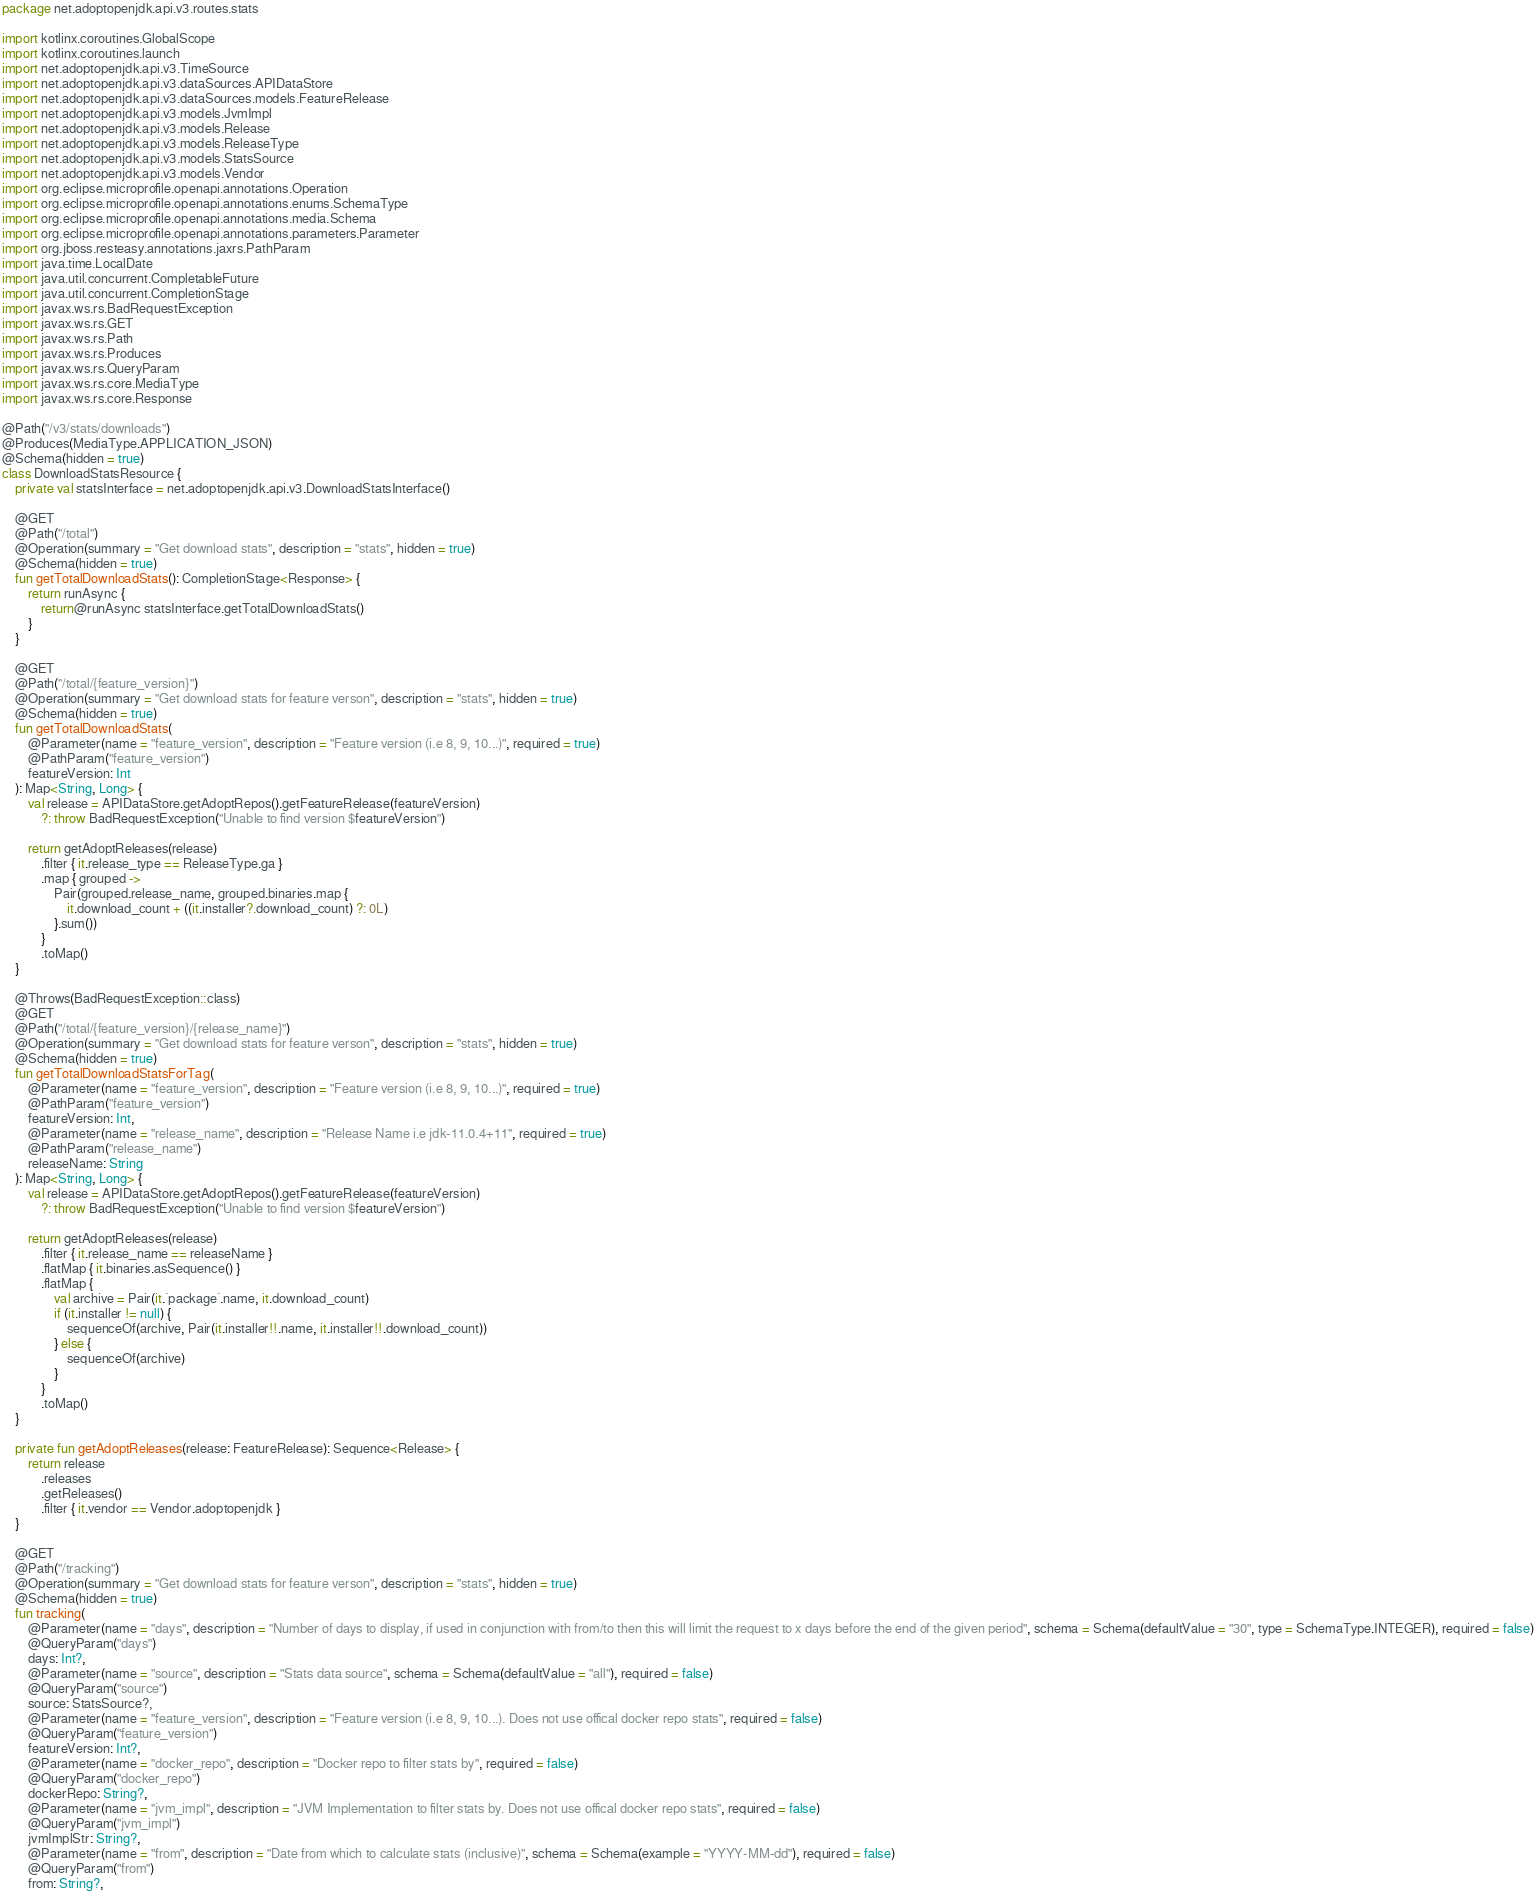Convert code to text. <code><loc_0><loc_0><loc_500><loc_500><_Kotlin_>package net.adoptopenjdk.api.v3.routes.stats

import kotlinx.coroutines.GlobalScope
import kotlinx.coroutines.launch
import net.adoptopenjdk.api.v3.TimeSource
import net.adoptopenjdk.api.v3.dataSources.APIDataStore
import net.adoptopenjdk.api.v3.dataSources.models.FeatureRelease
import net.adoptopenjdk.api.v3.models.JvmImpl
import net.adoptopenjdk.api.v3.models.Release
import net.adoptopenjdk.api.v3.models.ReleaseType
import net.adoptopenjdk.api.v3.models.StatsSource
import net.adoptopenjdk.api.v3.models.Vendor
import org.eclipse.microprofile.openapi.annotations.Operation
import org.eclipse.microprofile.openapi.annotations.enums.SchemaType
import org.eclipse.microprofile.openapi.annotations.media.Schema
import org.eclipse.microprofile.openapi.annotations.parameters.Parameter
import org.jboss.resteasy.annotations.jaxrs.PathParam
import java.time.LocalDate
import java.util.concurrent.CompletableFuture
import java.util.concurrent.CompletionStage
import javax.ws.rs.BadRequestException
import javax.ws.rs.GET
import javax.ws.rs.Path
import javax.ws.rs.Produces
import javax.ws.rs.QueryParam
import javax.ws.rs.core.MediaType
import javax.ws.rs.core.Response

@Path("/v3/stats/downloads")
@Produces(MediaType.APPLICATION_JSON)
@Schema(hidden = true)
class DownloadStatsResource {
    private val statsInterface = net.adoptopenjdk.api.v3.DownloadStatsInterface()

    @GET
    @Path("/total")
    @Operation(summary = "Get download stats", description = "stats", hidden = true)
    @Schema(hidden = true)
    fun getTotalDownloadStats(): CompletionStage<Response> {
        return runAsync {
            return@runAsync statsInterface.getTotalDownloadStats()
        }
    }

    @GET
    @Path("/total/{feature_version}")
    @Operation(summary = "Get download stats for feature verson", description = "stats", hidden = true)
    @Schema(hidden = true)
    fun getTotalDownloadStats(
        @Parameter(name = "feature_version", description = "Feature version (i.e 8, 9, 10...)", required = true)
        @PathParam("feature_version")
        featureVersion: Int
    ): Map<String, Long> {
        val release = APIDataStore.getAdoptRepos().getFeatureRelease(featureVersion)
            ?: throw BadRequestException("Unable to find version $featureVersion")

        return getAdoptReleases(release)
            .filter { it.release_type == ReleaseType.ga }
            .map { grouped ->
                Pair(grouped.release_name, grouped.binaries.map {
                    it.download_count + ((it.installer?.download_count) ?: 0L)
                }.sum())
            }
            .toMap()
    }

    @Throws(BadRequestException::class)
    @GET
    @Path("/total/{feature_version}/{release_name}")
    @Operation(summary = "Get download stats for feature verson", description = "stats", hidden = true)
    @Schema(hidden = true)
    fun getTotalDownloadStatsForTag(
        @Parameter(name = "feature_version", description = "Feature version (i.e 8, 9, 10...)", required = true)
        @PathParam("feature_version")
        featureVersion: Int,
        @Parameter(name = "release_name", description = "Release Name i.e jdk-11.0.4+11", required = true)
        @PathParam("release_name")
        releaseName: String
    ): Map<String, Long> {
        val release = APIDataStore.getAdoptRepos().getFeatureRelease(featureVersion)
            ?: throw BadRequestException("Unable to find version $featureVersion")

        return getAdoptReleases(release)
            .filter { it.release_name == releaseName }
            .flatMap { it.binaries.asSequence() }
            .flatMap {
                val archive = Pair(it.`package`.name, it.download_count)
                if (it.installer != null) {
                    sequenceOf(archive, Pair(it.installer!!.name, it.installer!!.download_count))
                } else {
                    sequenceOf(archive)
                }
            }
            .toMap()
    }

    private fun getAdoptReleases(release: FeatureRelease): Sequence<Release> {
        return release
            .releases
            .getReleases()
            .filter { it.vendor == Vendor.adoptopenjdk }
    }

    @GET
    @Path("/tracking")
    @Operation(summary = "Get download stats for feature verson", description = "stats", hidden = true)
    @Schema(hidden = true)
    fun tracking(
        @Parameter(name = "days", description = "Number of days to display, if used in conjunction with from/to then this will limit the request to x days before the end of the given period", schema = Schema(defaultValue = "30", type = SchemaType.INTEGER), required = false)
        @QueryParam("days")
        days: Int?,
        @Parameter(name = "source", description = "Stats data source", schema = Schema(defaultValue = "all"), required = false)
        @QueryParam("source")
        source: StatsSource?,
        @Parameter(name = "feature_version", description = "Feature version (i.e 8, 9, 10...). Does not use offical docker repo stats", required = false)
        @QueryParam("feature_version")
        featureVersion: Int?,
        @Parameter(name = "docker_repo", description = "Docker repo to filter stats by", required = false)
        @QueryParam("docker_repo")
        dockerRepo: String?,
        @Parameter(name = "jvm_impl", description = "JVM Implementation to filter stats by. Does not use offical docker repo stats", required = false)
        @QueryParam("jvm_impl")
        jvmImplStr: String?,
        @Parameter(name = "from", description = "Date from which to calculate stats (inclusive)", schema = Schema(example = "YYYY-MM-dd"), required = false)
        @QueryParam("from")
        from: String?,</code> 